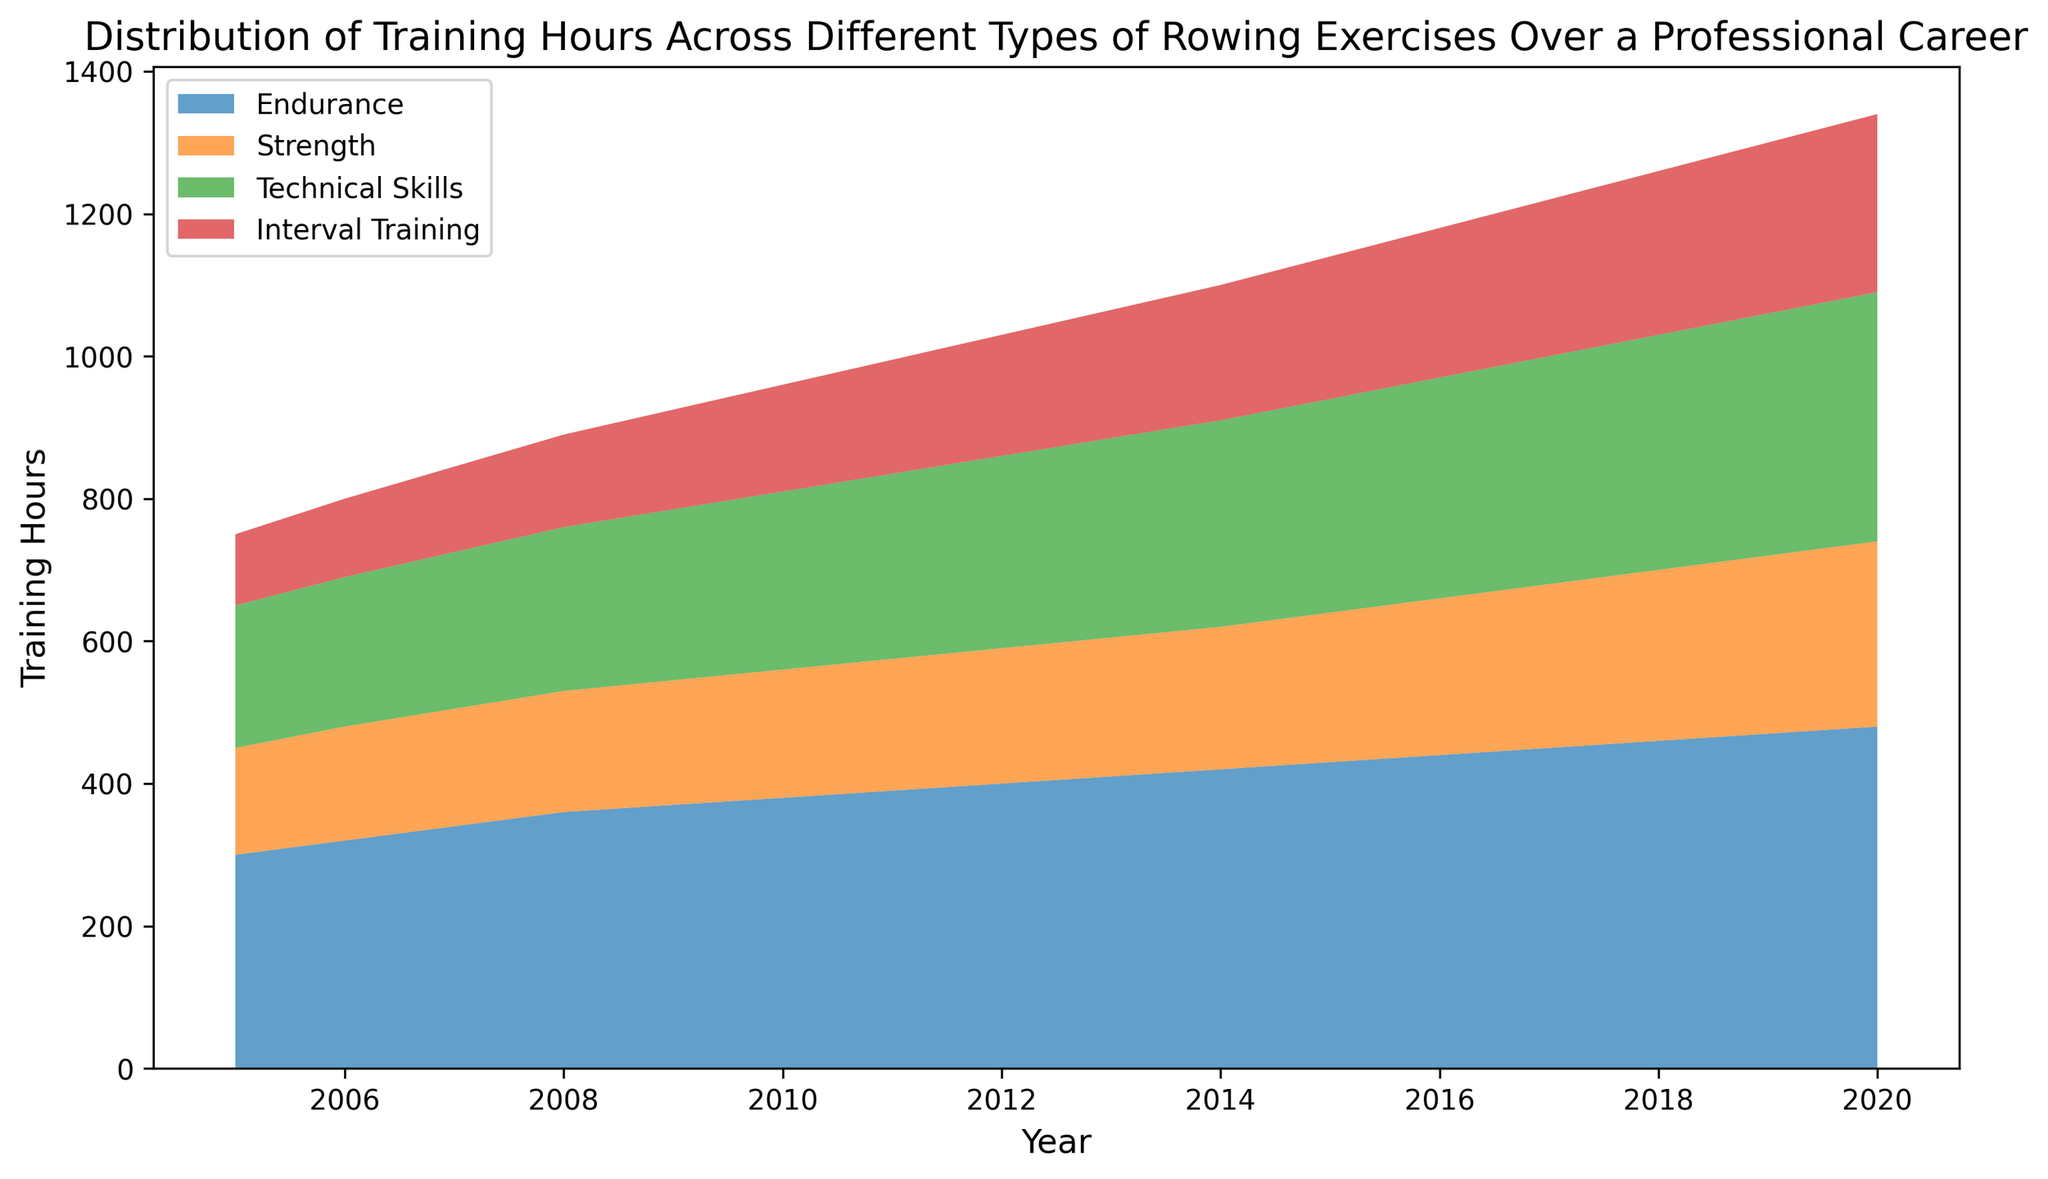Which type of rowing exercise had the most training hours in 2015? Look at the height of each segment in the stacked area corresponding to 2015 and identify the tallest one. In 2015, the "Endurance" segment is the tallest.
Answer: Endurance How do the total training hours in 2006 compare to those in 2012? To compare, add up the training hours for all exercise types in both years. The sum for 2006 is 320 + 160 + 210 + 110 = 800 and for 2012 is 400 + 190 + 270 + 170 = 1030.
Answer: 1030 > 800 Are the training hours for Strength exercises consistently increasing over the years? Observe the "Strength" area segment over the years 2005 to 2020. The height of this segment sequentially increases each year, indicating a consistent increase.
Answer: Yes Which year showed the highest single-year total training hours for all exercises combined? Sum up the training hours for each year and identify the maximum. The highest total occurrence is in 2020 with 480 + 260 + 350 + 250 = 1340.
Answer: 2020 By how much did the training hours for Technical Skills change from 2010 to 2017? Subtract the Technical Skills hours in 2010 from those in 2017. The calculation is 320 - 250 = 70.
Answer: 70 What is the average amount of training hours for Interval Training between 2010 and 2014? Sum the training hours for Interval Training from 2010 to 2014 and divide by the number of years. (150 + 160 + 170 + 180 + 190) / 5 = 170 hours.
Answer: 170 Which exercise type had the least amount of training hours in 2005? Examine the height of each segment corresponding to 2005 and identify the smallest one. In 2005, "Interval Training" has the smallest segment.
Answer: Interval Training From 2005 to 2020, which exercise type showed the greatest increase in training hours? Subtract the training hours in 2005 from those in 2020 for all exercise types and identify the largest difference: 
Endurance: 480 - 300 = 180
Strength: 260 - 150 = 110
Technical Skills: 350 - 200 = 150
Interval Training: 250 - 100 = 150
Endurance shows the greatest increase.
Answer: Endurance Between 2015 and 2019, which exercise type had the largest increase in training hours? Subtract the training hours in 2015 from those in 2019 for all exercise types and find the largest difference:
Endurance: 470 - 430 = 40
Strength: 250 - 210 = 40
Technical Skills: 340 - 300 = 40
Interval Training: 240 - 200 = 40
There is a tie between all types, each with an increase of 40 hours.
Answer: All types have equal increase 